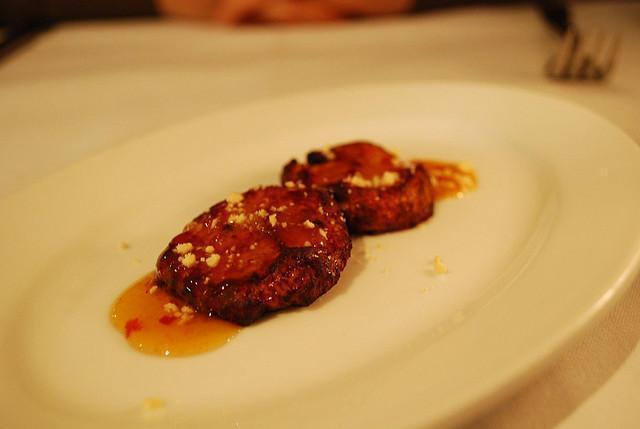How many pieces of food are on the plate?
Give a very brief answer. 2. How many donuts can be seen?
Give a very brief answer. 2. How many people have on blue backpacks?
Give a very brief answer. 0. 